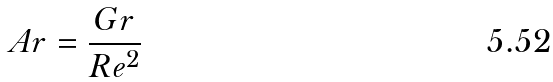<formula> <loc_0><loc_0><loc_500><loc_500>A r = \frac { G r } { R e ^ { 2 } }</formula> 